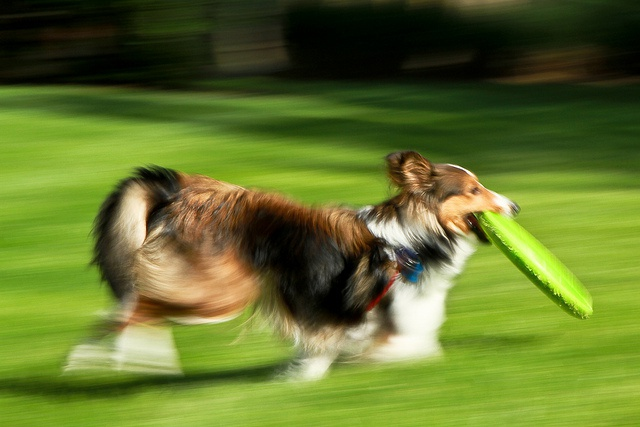Describe the objects in this image and their specific colors. I can see dog in black, tan, olive, and khaki tones and frisbee in black, yellow, lime, green, and khaki tones in this image. 